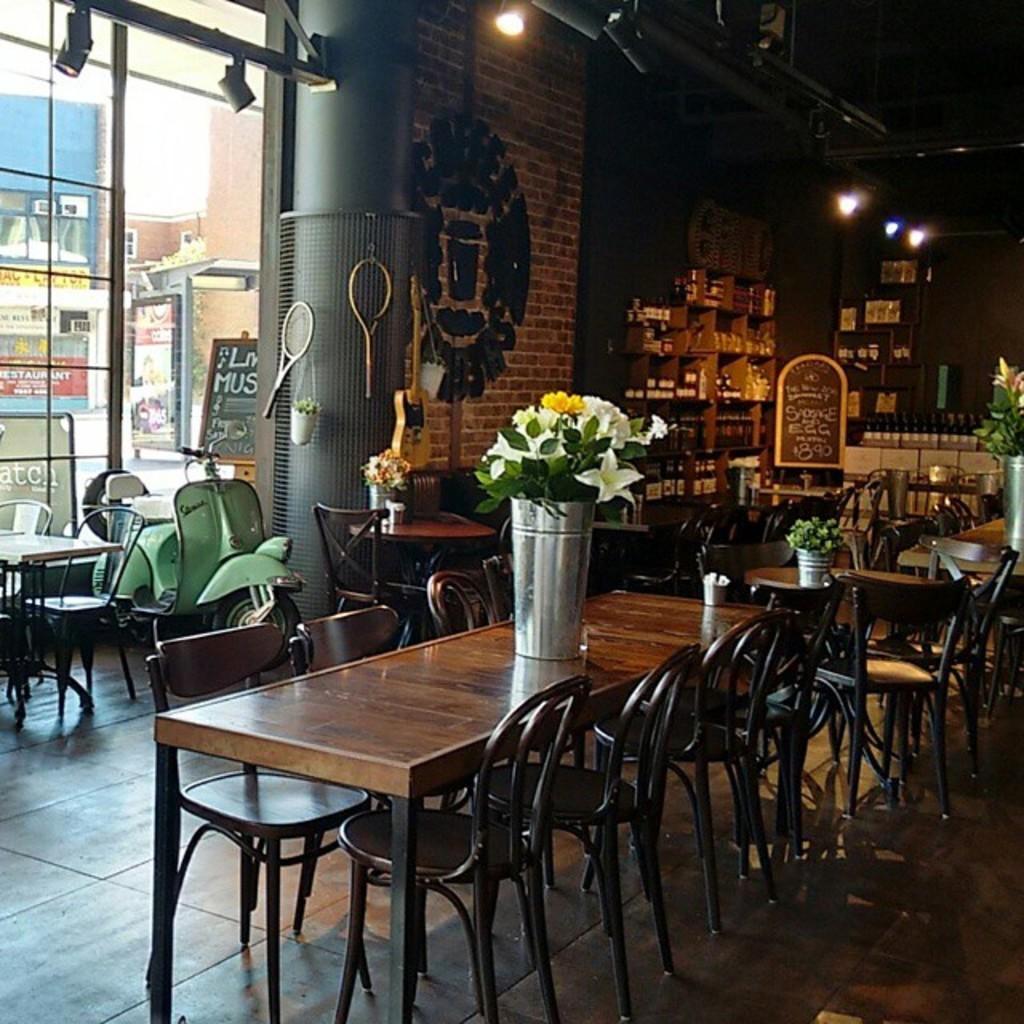Describe this image in one or two sentences. In this picture we can see a few flower vases and other things on the tables. There are a few chairs visible on the ground. We can see a vehicle. There is some text visible on the boards. We can see the bats. There are a few objects visible on the shelves. We can see my bottles and lights are visible on top. There is some text visible on a brick wall. We can see a few glass objects. Through these glass objects, we can see some things. There is a building visible in the background. 